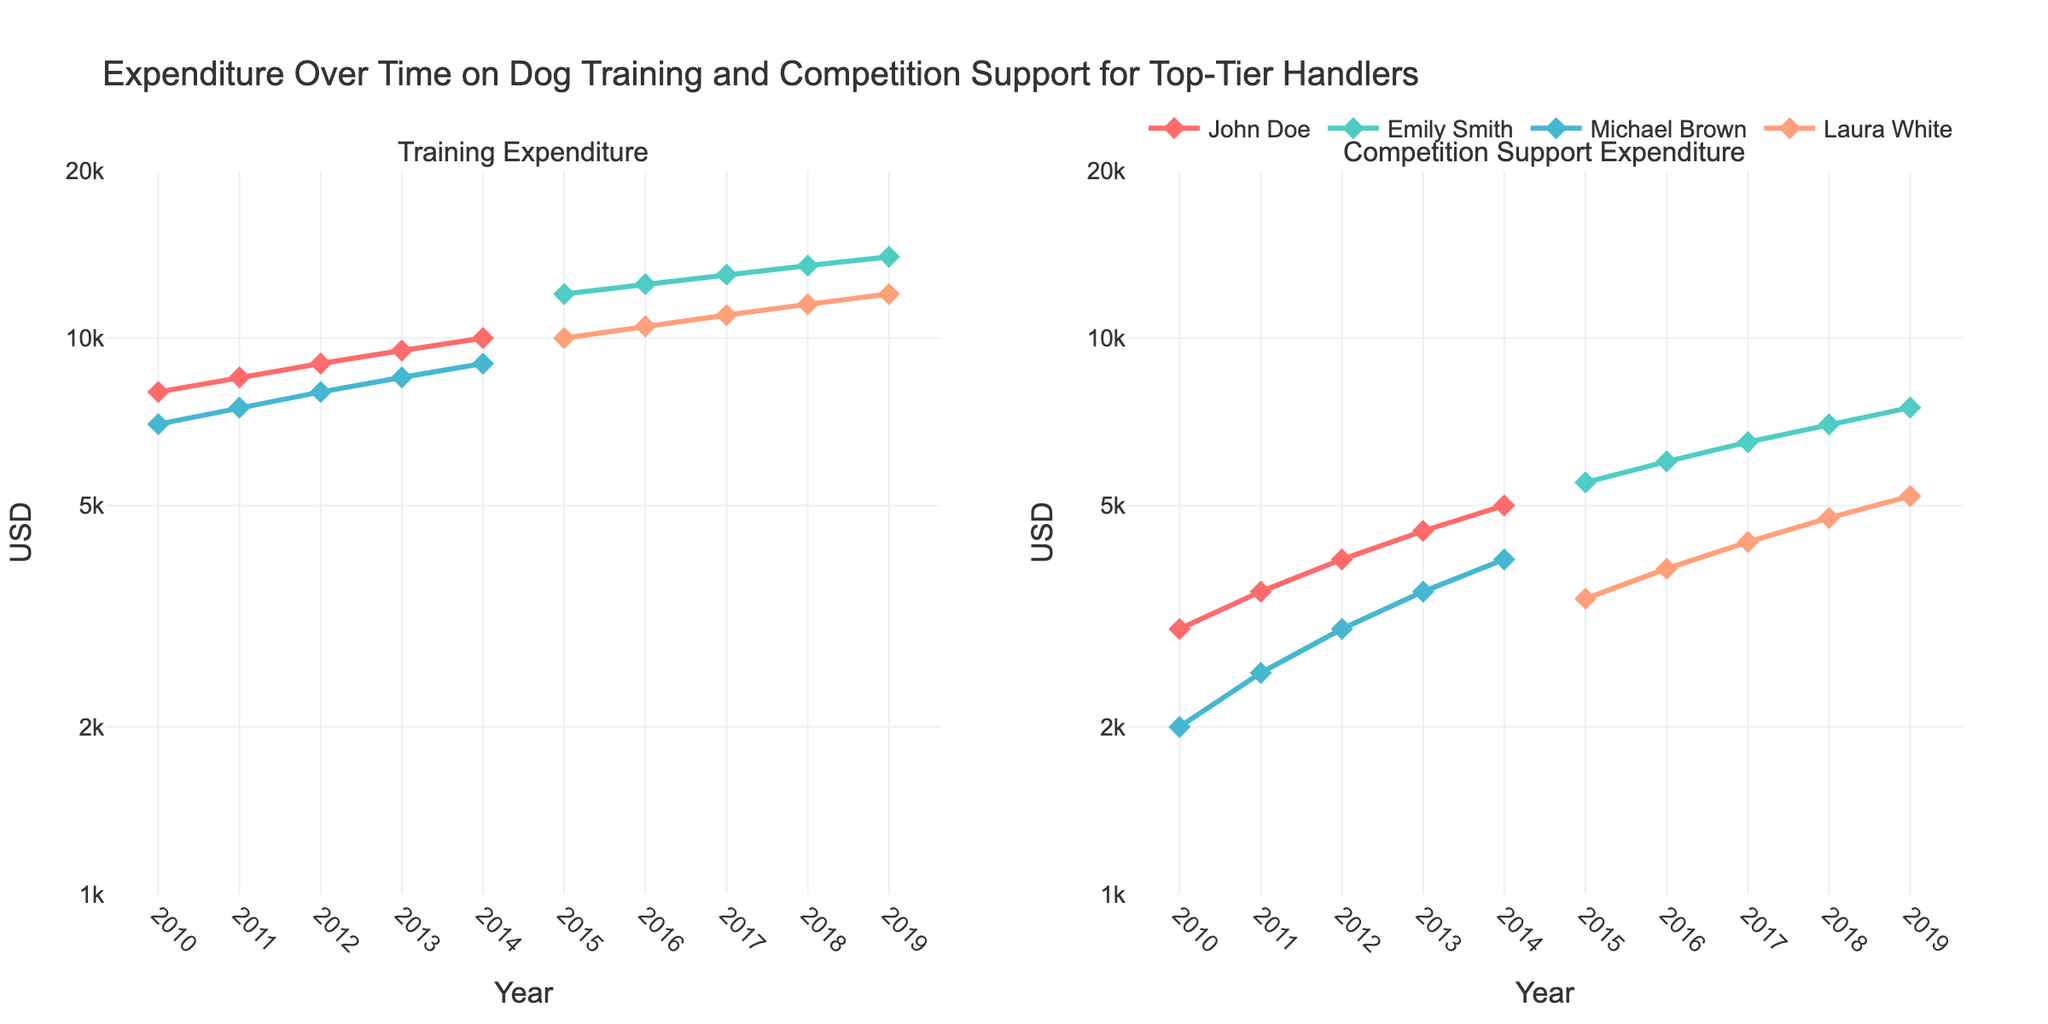What's the title of the figure? The title is usually displayed at the top of the figure. In this case, the title can be seen as "Expenditure Over Time on Dog Training and Competition Support for Top-Tier Handlers".
Answer: Expenditure Over Time on Dog Training and Competition Support for Top-Tier Handlers What is the Y-axis scale type in both subplots? The Y-axis scale type is indicated by the labels and ticks on the axes. Here, the Y-axis has log scale because the tick values are exponentially spaced (e.g., 1k, 2k, 5k, 10k, 20k).
Answer: Log scale What is the year with the highest Training Expenditure for Emily Smith? The highest Training Expenditure for Emily Smith can be seen at the end of her trace. In 2019, the expenditure is at its peak of $14,000.
Answer: 2019 Who had the lowest initial Competition Support Expenditure and what was the amount? The lowest initial Competition Support Expenditure can be identified by comparing the starting points of the handlers. Michael Brown had the lowest with an expenditure of $2,000 in 2010.
Answer: Michael Brown, $2,000 How does the Training Expenditure trend for John Doe compare to that of Michael Brown? By observing the trends, both John Doe and Michael Brown's Training Expenditure increases over time. However, John Doe's expenditure starts higher and ends higher relative to Michael Brown.
Answer: Both increase, but John Doe's is consistently higher What is the difference in Competition Support Expenditure between Emily Smith in 2015 and Laura White in 2015? Emily Smith's Competition Support Expenditure in 2015 is $5,500 and Laura White's is $3,400. The difference is $5,500 - $3,400 = $2,100.
Answer: $2,100 In which year did Laura White's Training Expenditure reach $10,000? By following Laura White's trace in the Training Expenditure subplot, we see that it reaches $10,000 in the year 2015.
Answer: 2015 Who had the steepest increase in Competition Support Expenditure over the observed period? The steepness of the increase can be judged by the slope of the lines. Emily Smith shows the steepest increase from $3,000 in 2010 to $7,500 in 2019.
Answer: Emily Smith What is the average Training Expenditure in 2014 across all handlers? Adding up the training expenditures for all handlers in 2014 ($10,000 + $9,000 + $9,000) and then dividing by the number of handlers (3) results in (10,000 + 9,000 + 9,000)/3 = 9,333.33.
Answer: $9,333.33 Which handler had the most consistent (least volatile) increase in Training Expenditure? Consistency can be judged by how evenly the expenditure increases over time without sudden jumps. John Doe's expenditure increases by a uniform $500 each year.
Answer: John Doe 